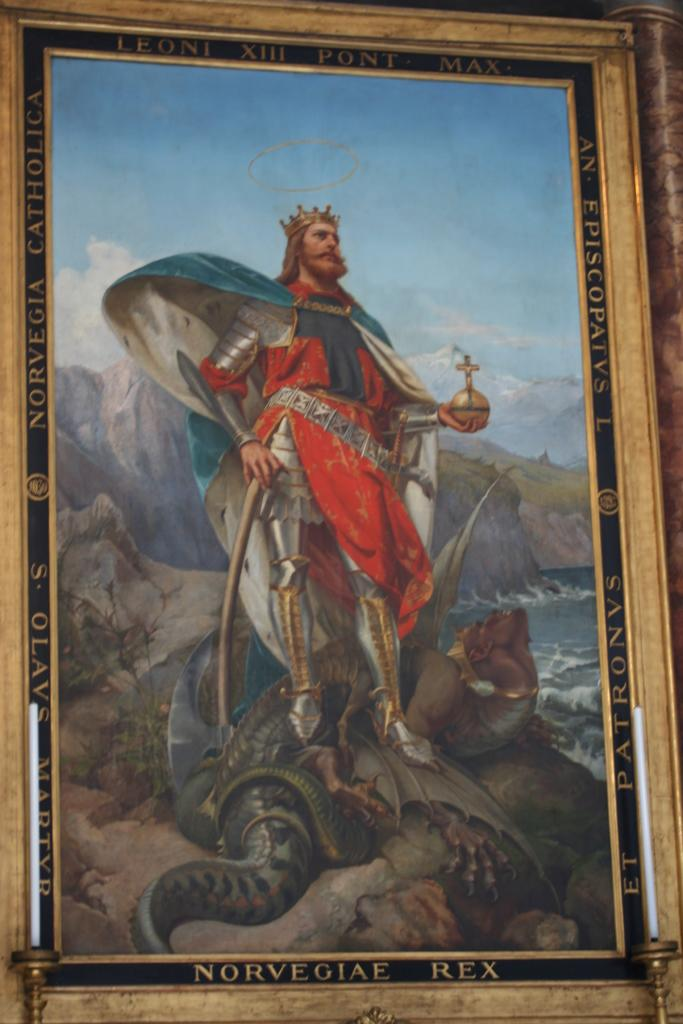Provide a one-sentence caption for the provided image. A painting of a crusade era knight wearing a crown and standing atop a slain dragon framed with the words Leone XIII Pont Max at the top. 